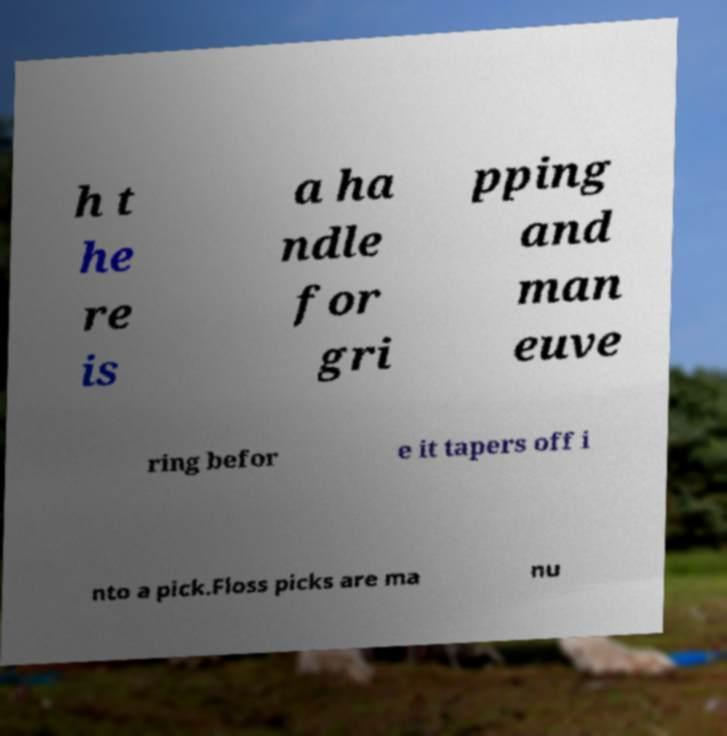Please read and relay the text visible in this image. What does it say? h t he re is a ha ndle for gri pping and man euve ring befor e it tapers off i nto a pick.Floss picks are ma nu 